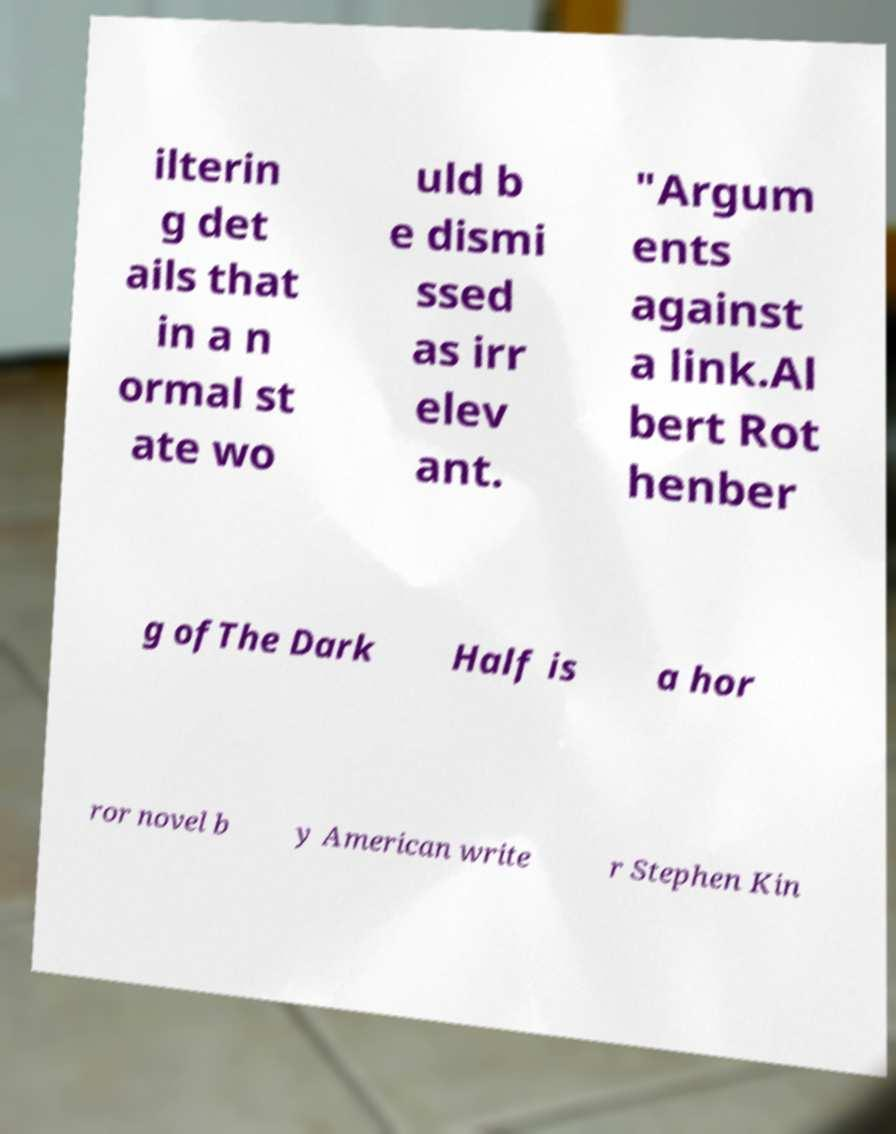Please read and relay the text visible in this image. What does it say? ilterin g det ails that in a n ormal st ate wo uld b e dismi ssed as irr elev ant. "Argum ents against a link.Al bert Rot henber g ofThe Dark Half is a hor ror novel b y American write r Stephen Kin 